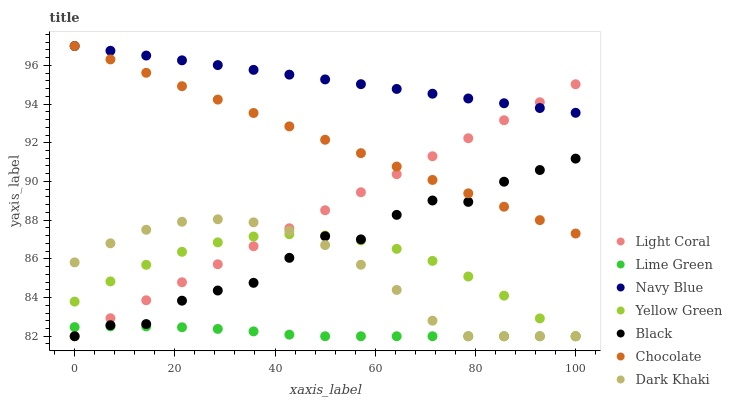Does Lime Green have the minimum area under the curve?
Answer yes or no. Yes. Does Navy Blue have the maximum area under the curve?
Answer yes or no. Yes. Does Yellow Green have the minimum area under the curve?
Answer yes or no. No. Does Yellow Green have the maximum area under the curve?
Answer yes or no. No. Is Navy Blue the smoothest?
Answer yes or no. Yes. Is Black the roughest?
Answer yes or no. Yes. Is Yellow Green the smoothest?
Answer yes or no. No. Is Yellow Green the roughest?
Answer yes or no. No. Does Dark Khaki have the lowest value?
Answer yes or no. Yes. Does Navy Blue have the lowest value?
Answer yes or no. No. Does Chocolate have the highest value?
Answer yes or no. Yes. Does Yellow Green have the highest value?
Answer yes or no. No. Is Black less than Navy Blue?
Answer yes or no. Yes. Is Navy Blue greater than Black?
Answer yes or no. Yes. Does Lime Green intersect Dark Khaki?
Answer yes or no. Yes. Is Lime Green less than Dark Khaki?
Answer yes or no. No. Is Lime Green greater than Dark Khaki?
Answer yes or no. No. Does Black intersect Navy Blue?
Answer yes or no. No. 